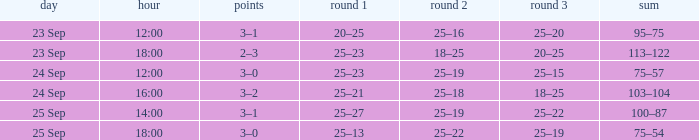What was the score when the time was 14:00? 3–1. 